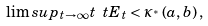Convert formula to latex. <formula><loc_0><loc_0><loc_500><loc_500>\lim s u p _ { t \to \infty } t \ t E _ { t } < \kappa _ { ^ { * } } \left ( a , b \right ) ,</formula> 